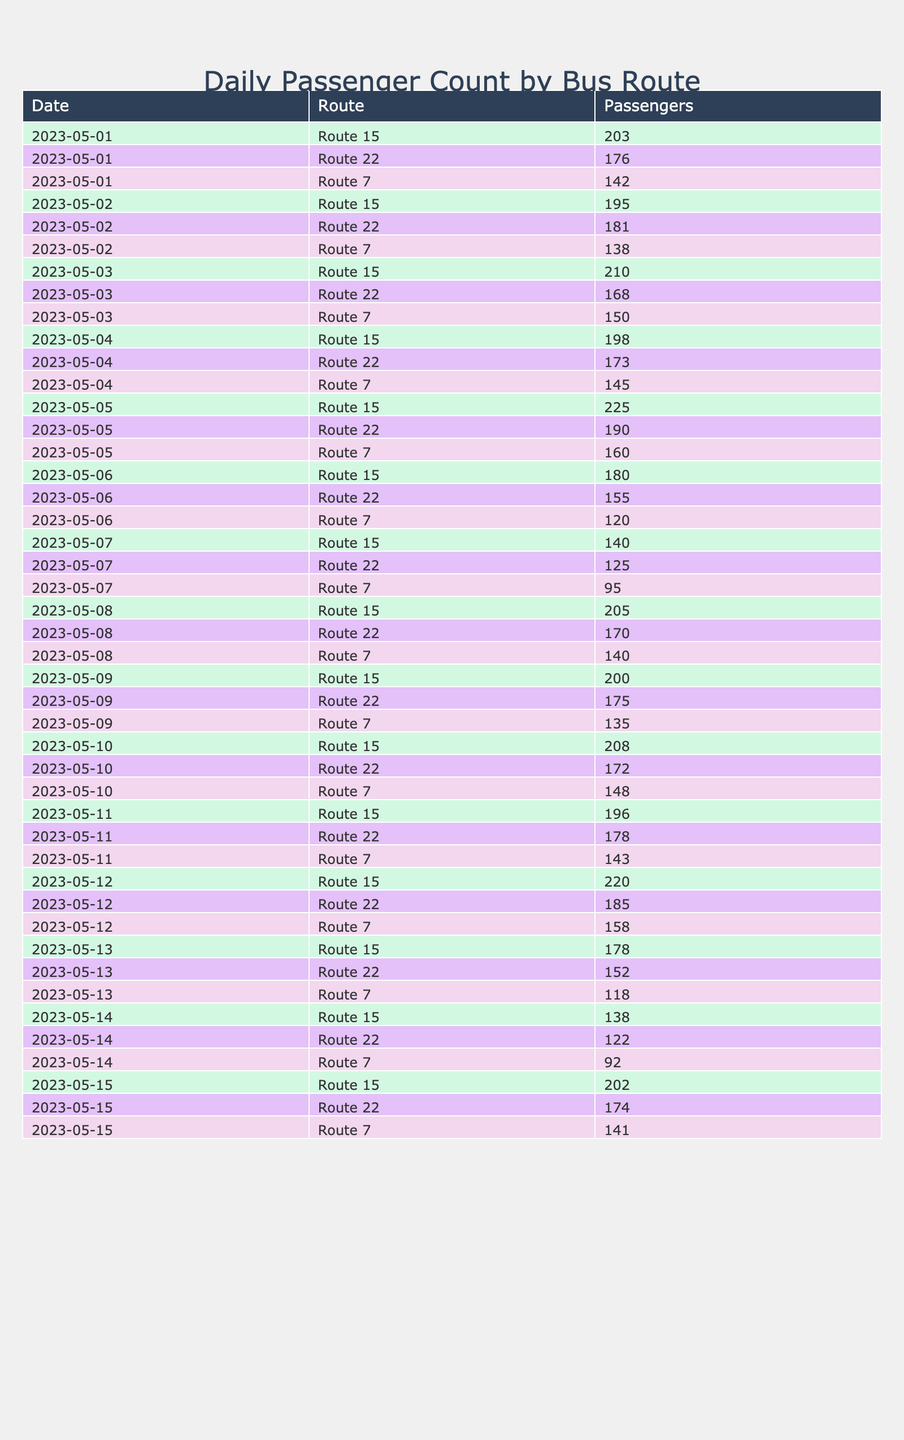What was the highest passenger count on Route 15? Reviewing the table, we find the highest number of passengers for Route 15 occurred on May 5th, with a total of 225 passengers.
Answer: 225 What is the total number of passengers for Route 7 throughout the week of May 1st to May 7th? To find the total for Route 7 in that week, we sum the passengers: 142 + 138 + 150 + 145 + 160 + 120 + 95 = 950.
Answer: 950 On which date did Route 22 have the lowest passenger count? Checking the table, the lowest passenger count for Route 22 was on May 14th, where only 122 passengers were counted.
Answer: May 14 Did Route 15 have more passengers than Route 22 on May 12th? Looking at both routes on May 12th, Route 15 had 220 passengers and Route 22 had 185 passengers. Since 220 is greater than 185, the answer is yes.
Answer: Yes What is the average number of passengers for Route 7 for the entire period in the table? The total number of passengers for Route 7 is found by adding all counts: 142 + 138 + 150 + 145 + 160 + 120 + 95 + 140 + 135 + 148 + 143 + 158 + 118 + 92 + 141 = 1747. As there are 15 days of data, the average is 1747 / 15 ≈ 116.47.
Answer: 116.47 Which route consistently had the highest passenger counts over the provided days? By analyzing the data, Route 15 consistently had the highest counts compared to Route 7 and Route 22 each day, particularly on May 5th with a peak of 225 passengers.
Answer: Route 15 What was the difference in passenger count between Route 15 and Route 22 on May 5th? On May 5th, Route 15 had 225 passengers and Route 22 had 190 passengers. The difference is calculated as 225 - 190 = 35.
Answer: 35 Over the entire month, how many days did Route 7 have passenger counts below 100? Examining the data, Route 7 recorded below 100 passengers on May 7th only, with 95 passengers. Thus, it was below 100 for just 1 day.
Answer: 1 Was the total number of passengers for Route 22 over all days greater than 2500? First, we sum Route 22's passenger counts: 176 + 181 + 168 + 173 + 190 + 155 + 125 + 170 + 175 + 172 + 178 + 185 + 152 + 122 + 174 = 2505. Since 2505 is greater than 2500, the answer is yes.
Answer: Yes 